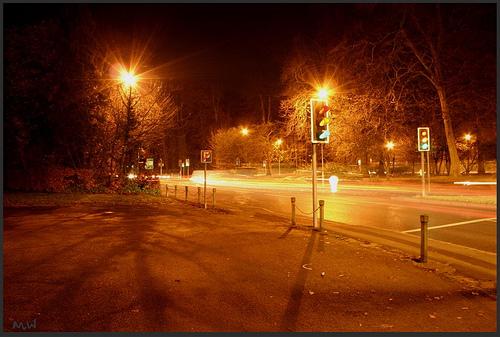Are there leaves on the trees?
Give a very brief answer. Yes. What color is lit up on the stop light?
Keep it brief. Green. Is the road empty or congested?
Keep it brief. Empty. Is there a stop sign here?
Give a very brief answer. No. How many lights are red?
Keep it brief. 0. Are all the lights the same color?
Give a very brief answer. No. How many cabs are in the picture?
Short answer required. 0. 